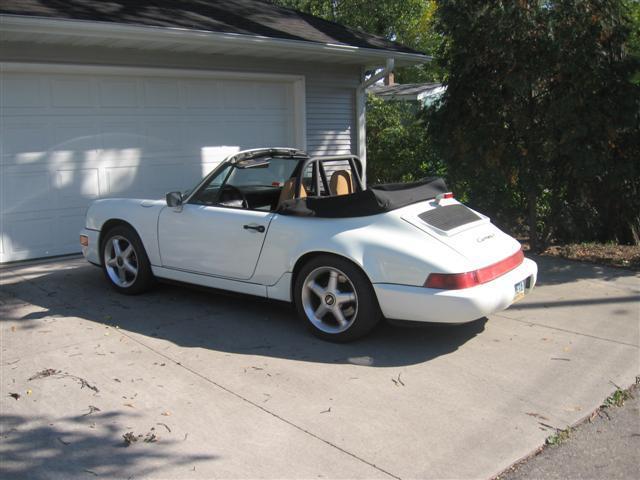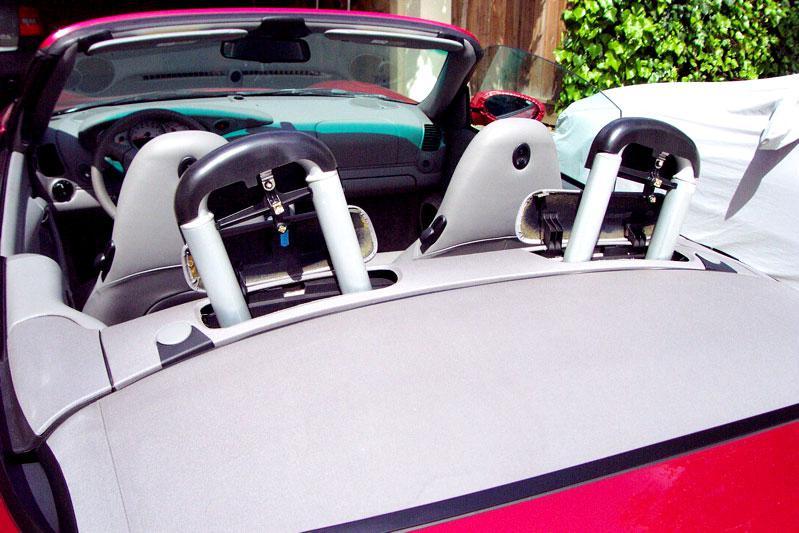The first image is the image on the left, the second image is the image on the right. Examine the images to the left and right. Is the description "The roll bars are visible in the image on the right." accurate? Answer yes or no. Yes. 